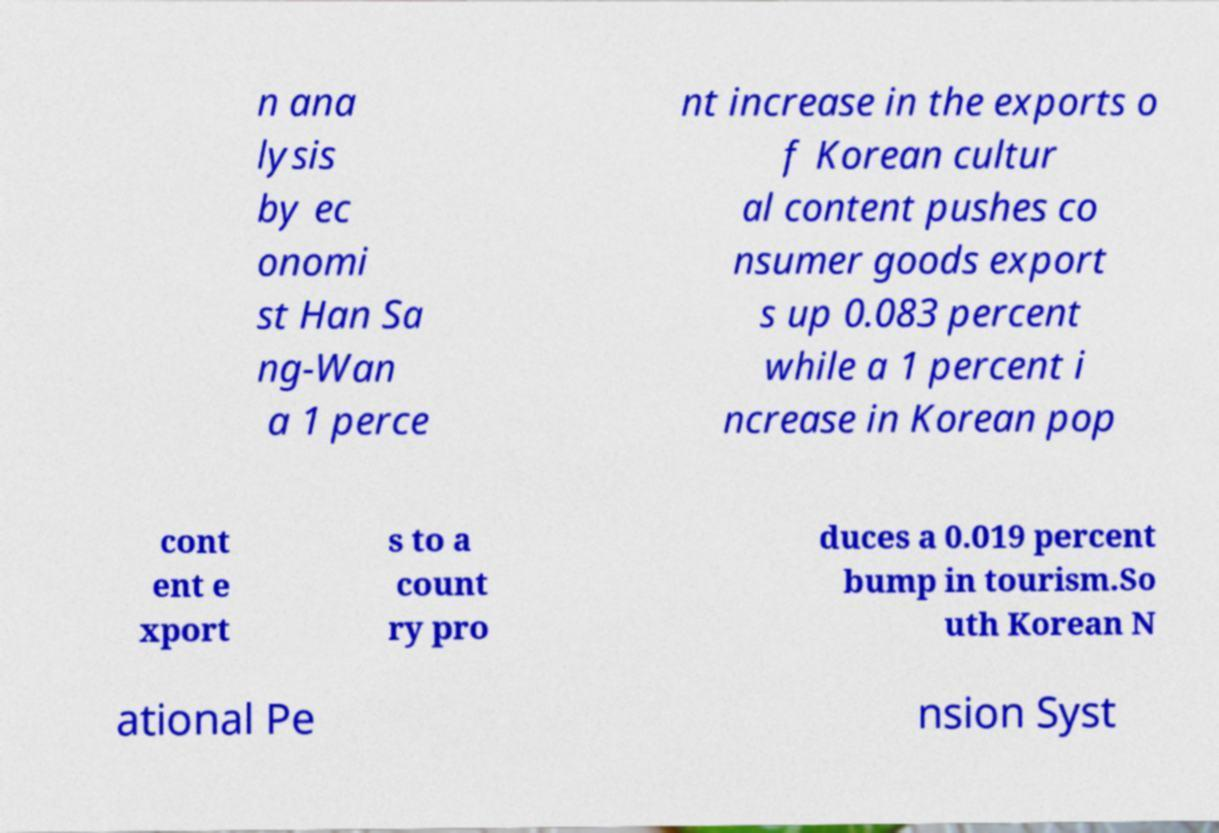Please read and relay the text visible in this image. What does it say? n ana lysis by ec onomi st Han Sa ng-Wan a 1 perce nt increase in the exports o f Korean cultur al content pushes co nsumer goods export s up 0.083 percent while a 1 percent i ncrease in Korean pop cont ent e xport s to a count ry pro duces a 0.019 percent bump in tourism.So uth Korean N ational Pe nsion Syst 